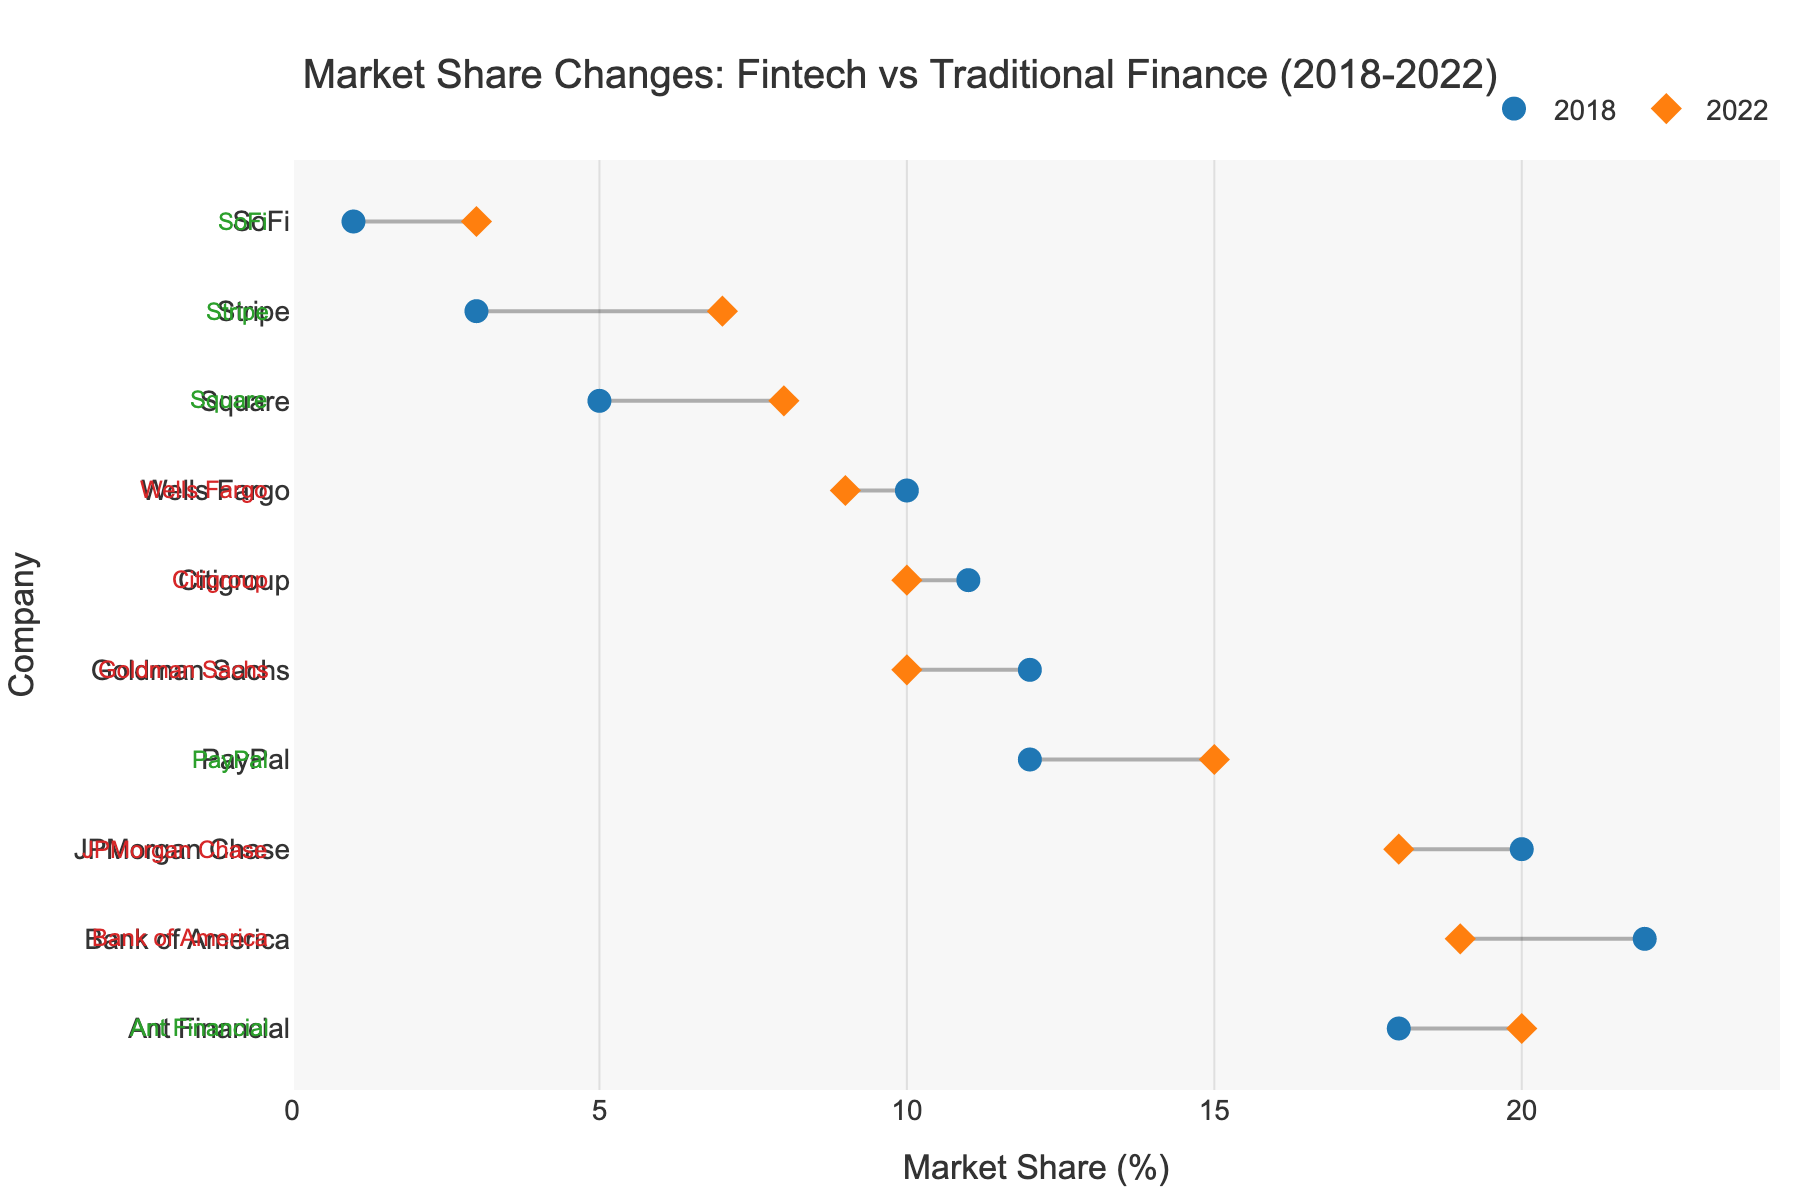What's the title of the figure? The title is located at the top of the figure. It provides a summary of what the figure is about.
Answer: Market Share Changes: Fintech vs Traditional Finance (2018-2022) What are the labels on the x-axis and y-axis? Axis labels provide context for the data points and help interpret the graph.
Answer: The x-axis is labeled 'Market Share (%)' and the y-axis is labeled 'Company' Which company had the highest market share in 2022? Look at the plot and see which company has the highest position on the x-axis for the 2022 markers.
Answer: Ant Financial How has the market share of JPMorgan Chase changed from 2018 to 2022? Compare the positions of the markers for JPMorgan Chase for the years 2018 and 2022.
Answer: It decreased from 20% to 18% Which traditional financial institution had the smallest decrease in market share? Compare the lengths of the lines for companies under the 'Traditional' type and choose the smallest one.
Answer: Citigroup By how many percentage points did the market share of PayPal increase from 2018 to 2022? Subtract PayPal's market share in 2018 from its market share in 2022.
Answer: 3 percentage points Which fintech company had the greatest increase in market share? Compare the lengths of the lines for companies under the 'Fintech' type and choose the longest one.
Answer: Stripe How many companies are there in total in this plot? Count the number of unique companies listed on the y-axis.
Answer: 10 companies Which company's market share remained unchanged, and why is this significant? Look for the company where the position on the x-axis for 2018 and 2022 markers are the same, signifying no change.
Answer: None; it's significant because all companies experienced some change in market share What trend can be observed for fintech companies compared to traditional financial institutions over these years? Compare the overall direction of movement (increase or decrease) for fintech companies versus traditional financial institutions in the dumbbell plot.
Answer: Fintech companies generally increased their market share, while traditional financial institutions mostly saw a decrease 